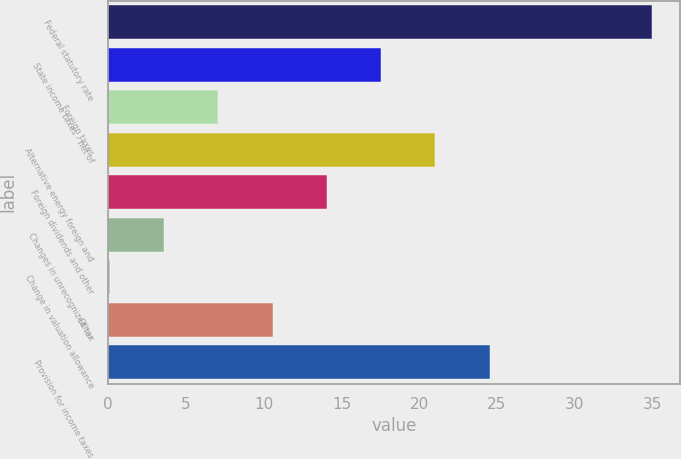<chart> <loc_0><loc_0><loc_500><loc_500><bar_chart><fcel>Federal statutory rate<fcel>State income taxes - net of<fcel>Foreign taxes<fcel>Alternative energy foreign and<fcel>Foreign dividends and other<fcel>Changes in unrecognized tax<fcel>Change in valuation allowance<fcel>Other<fcel>Provision for income taxes<nl><fcel>35<fcel>17.55<fcel>7.08<fcel>21.04<fcel>14.06<fcel>3.59<fcel>0.1<fcel>10.57<fcel>24.53<nl></chart> 